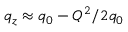<formula> <loc_0><loc_0><loc_500><loc_500>q _ { z } \approx q _ { 0 } - Q ^ { 2 } / 2 q _ { 0 }</formula> 